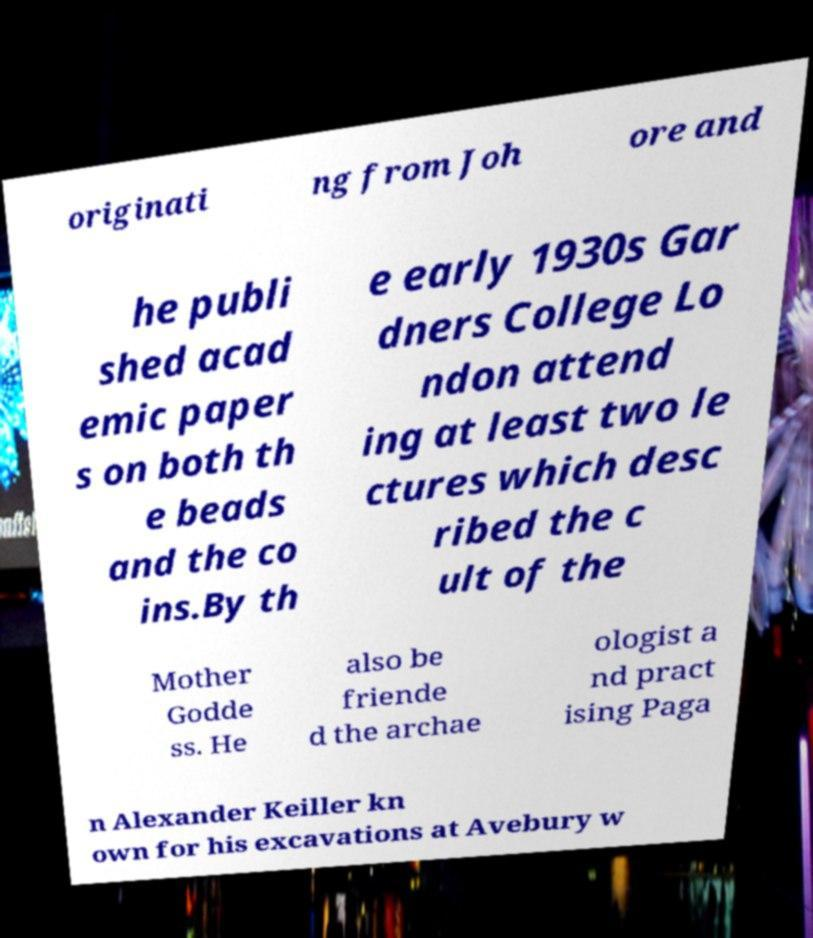There's text embedded in this image that I need extracted. Can you transcribe it verbatim? originati ng from Joh ore and he publi shed acad emic paper s on both th e beads and the co ins.By th e early 1930s Gar dners College Lo ndon attend ing at least two le ctures which desc ribed the c ult of the Mother Godde ss. He also be friende d the archae ologist a nd pract ising Paga n Alexander Keiller kn own for his excavations at Avebury w 